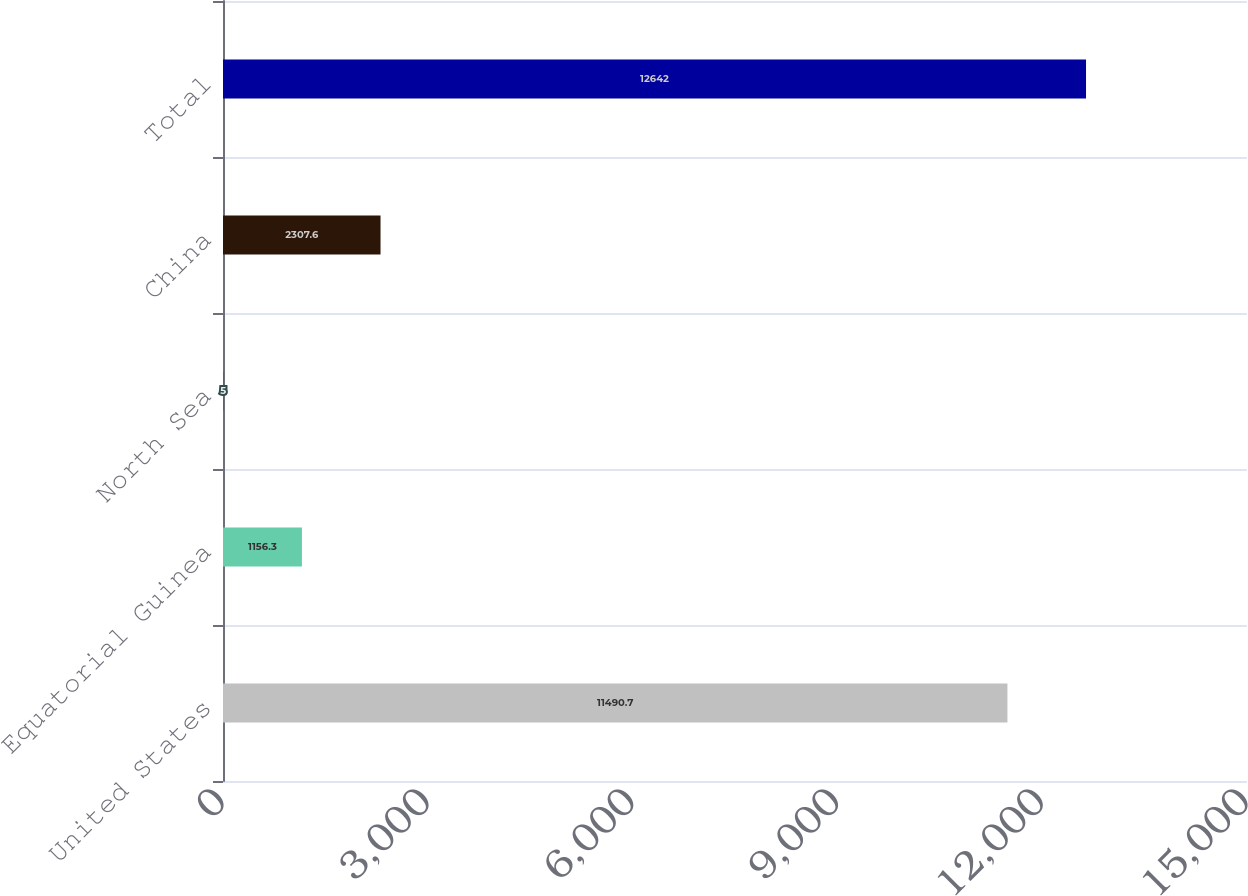<chart> <loc_0><loc_0><loc_500><loc_500><bar_chart><fcel>United States<fcel>Equatorial Guinea<fcel>North Sea<fcel>China<fcel>Total<nl><fcel>11490.7<fcel>1156.3<fcel>5<fcel>2307.6<fcel>12642<nl></chart> 